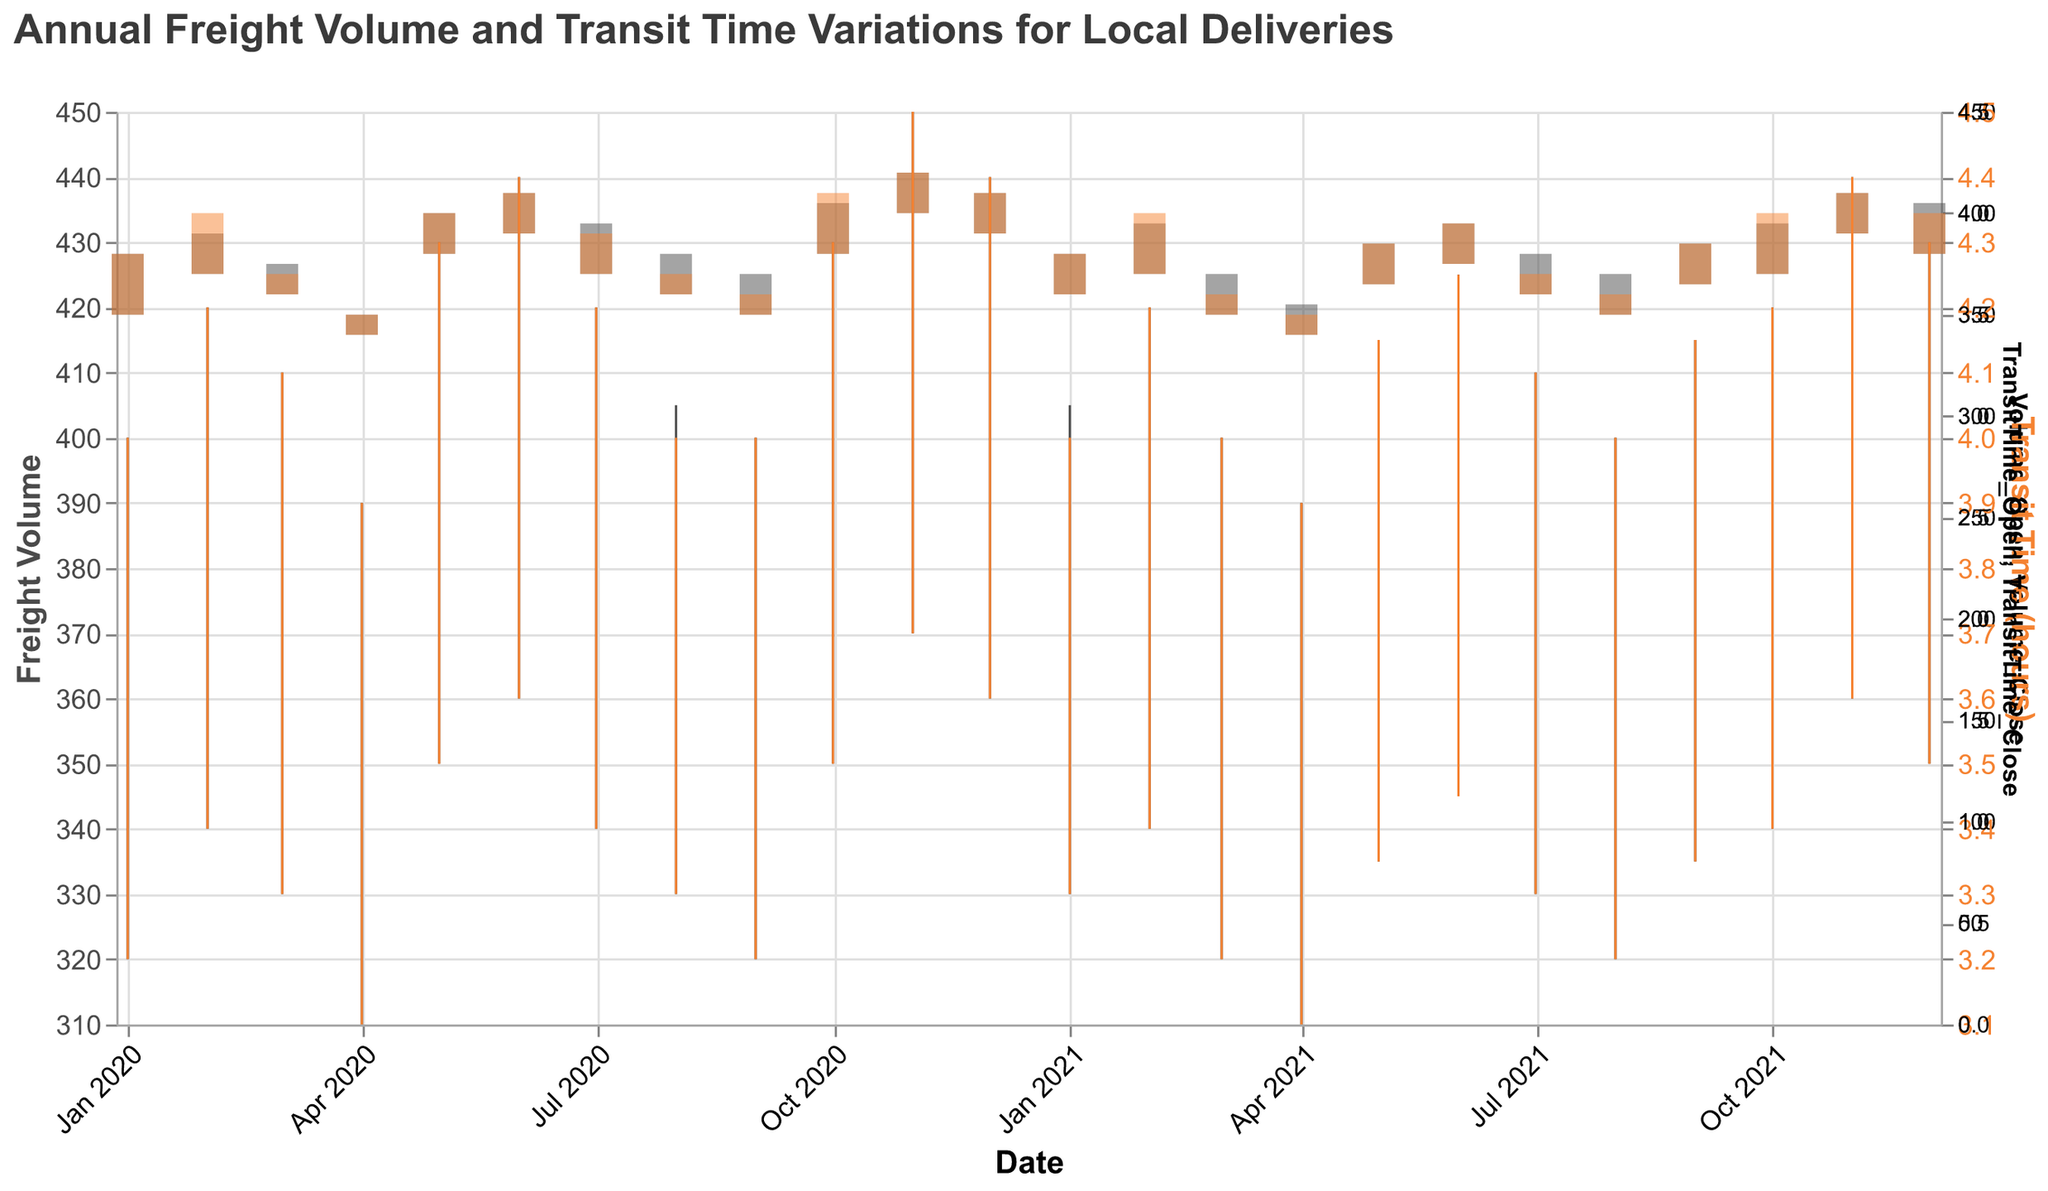How does the freight volume vary throughout the year? To see how the freight volume varies, look at the candlestick bars representing "Volume" values (open, high, low, close) for each month. Look for patterns, such as higher volumes in certain months. Notably, November 2020 had the highest recorded freight volume with a high of 450 and a low of 370.
Answer: Highest in November 2020 What's the trend in transit times over the two years? Examine the orange bars and lines representing "Transit Time". Notice any patterns or changes over the two years. The trend is generally stable, with slight variations, peaking in November 2020 at a high of 4.5 hours.
Answer: Generally stable Which month had the highest freight volume and what was the value? Look at the highest sections of the bars plotted in the figure, which indicates the highest freight volume recorded each month. November 2020 had the highest freight volume at 450.
Answer: November 2020, 450 Did the transit time tend to rise or fall at the end of each year? Compare the Transit Time (orange) bars and lines, specifically in November and December for the given years. The trend shows a slight increase in transit time towards the end of each year.
Answer: Slightly increased In which month and year was the largest drop in freight volume observed from open to close? To find this, compare the "Volume_Open" and "Volume_Close" values for each month. The largest drop occurred in April 2020, from 340 to 350.
Answer: April 2020 What was the range of transit times in May 2020? Identify the "TransitTime_Low" and "TransitTime_High" in May 2020 from the figure and calculate the range. The range is the difference between 4.3 and 3.5, which is 0.8 hours.
Answer: 0.8 hours How does the freight volume in December 2020 compare to December 2021? Compare the "Volume_Open" and "Volume_Close" candlestick bars of December 2020 and December 2021. Both months show a closing value of 410, indicating no change in freight volume.
Answer: The same, 410 Which month experienced the least variation in transit times in 2021 and what was the value? Look for the smallest difference between "TransitTime_Low" and "TransitTime_High" in 2021. For example, January 2021 had the least variation with a difference of (4.0 - 3.3) hours, which is 0.7 hours.
Answer: January 2021, 0.7 hours Was there any month where the freight volume was consistently higher (open and close values) than the previous month? Check if "Volume_Open" and "Volume_Close" values for any month are both higher compared to the previous month. For example, in February 2020, both the open (370 vs 350) and close (390 vs 380) were higher than January.
Answer: February 2020 